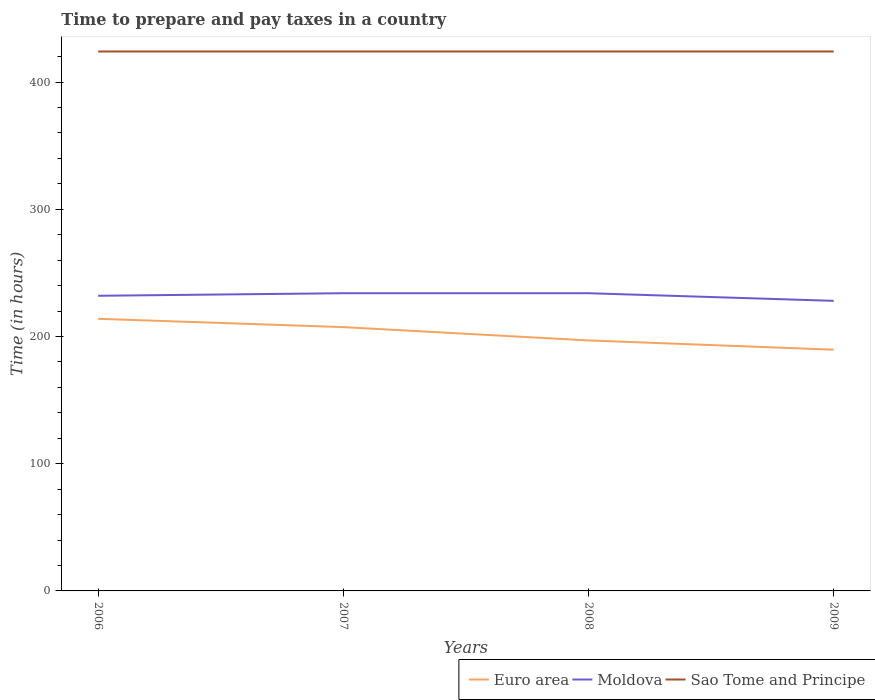Across all years, what is the maximum number of hours required to prepare and pay taxes in Euro area?
Your response must be concise. 189.61. What is the total number of hours required to prepare and pay taxes in Moldova in the graph?
Offer a terse response. -2. What is the difference between the highest and the second highest number of hours required to prepare and pay taxes in Moldova?
Provide a succinct answer. 6. How many years are there in the graph?
Your response must be concise. 4. What is the difference between two consecutive major ticks on the Y-axis?
Keep it short and to the point. 100. Are the values on the major ticks of Y-axis written in scientific E-notation?
Your answer should be very brief. No. Does the graph contain any zero values?
Offer a terse response. No. Does the graph contain grids?
Give a very brief answer. No. How many legend labels are there?
Offer a terse response. 3. How are the legend labels stacked?
Provide a succinct answer. Horizontal. What is the title of the graph?
Ensure brevity in your answer.  Time to prepare and pay taxes in a country. Does "Puerto Rico" appear as one of the legend labels in the graph?
Make the answer very short. No. What is the label or title of the X-axis?
Offer a terse response. Years. What is the label or title of the Y-axis?
Your response must be concise. Time (in hours). What is the Time (in hours) in Euro area in 2006?
Make the answer very short. 213.88. What is the Time (in hours) of Moldova in 2006?
Offer a very short reply. 232. What is the Time (in hours) in Sao Tome and Principe in 2006?
Provide a short and direct response. 424. What is the Time (in hours) of Euro area in 2007?
Your answer should be very brief. 207.35. What is the Time (in hours) in Moldova in 2007?
Give a very brief answer. 234. What is the Time (in hours) in Sao Tome and Principe in 2007?
Offer a terse response. 424. What is the Time (in hours) of Euro area in 2008?
Keep it short and to the point. 196.89. What is the Time (in hours) in Moldova in 2008?
Offer a very short reply. 234. What is the Time (in hours) of Sao Tome and Principe in 2008?
Your answer should be very brief. 424. What is the Time (in hours) in Euro area in 2009?
Ensure brevity in your answer.  189.61. What is the Time (in hours) in Moldova in 2009?
Your response must be concise. 228. What is the Time (in hours) in Sao Tome and Principe in 2009?
Provide a short and direct response. 424. Across all years, what is the maximum Time (in hours) of Euro area?
Provide a short and direct response. 213.88. Across all years, what is the maximum Time (in hours) of Moldova?
Offer a very short reply. 234. Across all years, what is the maximum Time (in hours) in Sao Tome and Principe?
Your answer should be very brief. 424. Across all years, what is the minimum Time (in hours) in Euro area?
Offer a very short reply. 189.61. Across all years, what is the minimum Time (in hours) of Moldova?
Ensure brevity in your answer.  228. Across all years, what is the minimum Time (in hours) in Sao Tome and Principe?
Provide a succinct answer. 424. What is the total Time (in hours) of Euro area in the graph?
Keep it short and to the point. 807.74. What is the total Time (in hours) of Moldova in the graph?
Your answer should be compact. 928. What is the total Time (in hours) in Sao Tome and Principe in the graph?
Your answer should be compact. 1696. What is the difference between the Time (in hours) of Euro area in 2006 and that in 2007?
Ensure brevity in your answer.  6.53. What is the difference between the Time (in hours) in Sao Tome and Principe in 2006 and that in 2007?
Offer a very short reply. 0. What is the difference between the Time (in hours) in Euro area in 2006 and that in 2008?
Keep it short and to the point. 16.99. What is the difference between the Time (in hours) in Sao Tome and Principe in 2006 and that in 2008?
Your answer should be compact. 0. What is the difference between the Time (in hours) in Euro area in 2006 and that in 2009?
Make the answer very short. 24.27. What is the difference between the Time (in hours) in Moldova in 2006 and that in 2009?
Keep it short and to the point. 4. What is the difference between the Time (in hours) of Sao Tome and Principe in 2006 and that in 2009?
Provide a short and direct response. 0. What is the difference between the Time (in hours) in Euro area in 2007 and that in 2008?
Provide a short and direct response. 10.46. What is the difference between the Time (in hours) in Moldova in 2007 and that in 2008?
Offer a very short reply. 0. What is the difference between the Time (in hours) in Sao Tome and Principe in 2007 and that in 2008?
Offer a very short reply. 0. What is the difference between the Time (in hours) of Euro area in 2007 and that in 2009?
Provide a short and direct response. 17.74. What is the difference between the Time (in hours) of Moldova in 2007 and that in 2009?
Ensure brevity in your answer.  6. What is the difference between the Time (in hours) of Sao Tome and Principe in 2007 and that in 2009?
Provide a short and direct response. 0. What is the difference between the Time (in hours) in Euro area in 2008 and that in 2009?
Your answer should be compact. 7.28. What is the difference between the Time (in hours) of Moldova in 2008 and that in 2009?
Keep it short and to the point. 6. What is the difference between the Time (in hours) in Euro area in 2006 and the Time (in hours) in Moldova in 2007?
Provide a short and direct response. -20.12. What is the difference between the Time (in hours) of Euro area in 2006 and the Time (in hours) of Sao Tome and Principe in 2007?
Offer a terse response. -210.12. What is the difference between the Time (in hours) of Moldova in 2006 and the Time (in hours) of Sao Tome and Principe in 2007?
Your response must be concise. -192. What is the difference between the Time (in hours) of Euro area in 2006 and the Time (in hours) of Moldova in 2008?
Provide a short and direct response. -20.12. What is the difference between the Time (in hours) in Euro area in 2006 and the Time (in hours) in Sao Tome and Principe in 2008?
Your response must be concise. -210.12. What is the difference between the Time (in hours) in Moldova in 2006 and the Time (in hours) in Sao Tome and Principe in 2008?
Offer a very short reply. -192. What is the difference between the Time (in hours) of Euro area in 2006 and the Time (in hours) of Moldova in 2009?
Offer a terse response. -14.12. What is the difference between the Time (in hours) in Euro area in 2006 and the Time (in hours) in Sao Tome and Principe in 2009?
Your response must be concise. -210.12. What is the difference between the Time (in hours) of Moldova in 2006 and the Time (in hours) of Sao Tome and Principe in 2009?
Offer a terse response. -192. What is the difference between the Time (in hours) in Euro area in 2007 and the Time (in hours) in Moldova in 2008?
Provide a succinct answer. -26.65. What is the difference between the Time (in hours) of Euro area in 2007 and the Time (in hours) of Sao Tome and Principe in 2008?
Offer a terse response. -216.65. What is the difference between the Time (in hours) in Moldova in 2007 and the Time (in hours) in Sao Tome and Principe in 2008?
Make the answer very short. -190. What is the difference between the Time (in hours) in Euro area in 2007 and the Time (in hours) in Moldova in 2009?
Ensure brevity in your answer.  -20.65. What is the difference between the Time (in hours) in Euro area in 2007 and the Time (in hours) in Sao Tome and Principe in 2009?
Your answer should be compact. -216.65. What is the difference between the Time (in hours) in Moldova in 2007 and the Time (in hours) in Sao Tome and Principe in 2009?
Ensure brevity in your answer.  -190. What is the difference between the Time (in hours) of Euro area in 2008 and the Time (in hours) of Moldova in 2009?
Your response must be concise. -31.11. What is the difference between the Time (in hours) of Euro area in 2008 and the Time (in hours) of Sao Tome and Principe in 2009?
Your answer should be compact. -227.11. What is the difference between the Time (in hours) of Moldova in 2008 and the Time (in hours) of Sao Tome and Principe in 2009?
Ensure brevity in your answer.  -190. What is the average Time (in hours) of Euro area per year?
Ensure brevity in your answer.  201.93. What is the average Time (in hours) of Moldova per year?
Your response must be concise. 232. What is the average Time (in hours) in Sao Tome and Principe per year?
Your answer should be very brief. 424. In the year 2006, what is the difference between the Time (in hours) in Euro area and Time (in hours) in Moldova?
Give a very brief answer. -18.12. In the year 2006, what is the difference between the Time (in hours) in Euro area and Time (in hours) in Sao Tome and Principe?
Offer a terse response. -210.12. In the year 2006, what is the difference between the Time (in hours) of Moldova and Time (in hours) of Sao Tome and Principe?
Provide a short and direct response. -192. In the year 2007, what is the difference between the Time (in hours) of Euro area and Time (in hours) of Moldova?
Provide a succinct answer. -26.65. In the year 2007, what is the difference between the Time (in hours) of Euro area and Time (in hours) of Sao Tome and Principe?
Your answer should be very brief. -216.65. In the year 2007, what is the difference between the Time (in hours) in Moldova and Time (in hours) in Sao Tome and Principe?
Your answer should be compact. -190. In the year 2008, what is the difference between the Time (in hours) in Euro area and Time (in hours) in Moldova?
Offer a terse response. -37.11. In the year 2008, what is the difference between the Time (in hours) of Euro area and Time (in hours) of Sao Tome and Principe?
Your answer should be very brief. -227.11. In the year 2008, what is the difference between the Time (in hours) of Moldova and Time (in hours) of Sao Tome and Principe?
Provide a short and direct response. -190. In the year 2009, what is the difference between the Time (in hours) in Euro area and Time (in hours) in Moldova?
Ensure brevity in your answer.  -38.39. In the year 2009, what is the difference between the Time (in hours) in Euro area and Time (in hours) in Sao Tome and Principe?
Your answer should be very brief. -234.39. In the year 2009, what is the difference between the Time (in hours) in Moldova and Time (in hours) in Sao Tome and Principe?
Your answer should be compact. -196. What is the ratio of the Time (in hours) of Euro area in 2006 to that in 2007?
Provide a succinct answer. 1.03. What is the ratio of the Time (in hours) in Sao Tome and Principe in 2006 to that in 2007?
Provide a short and direct response. 1. What is the ratio of the Time (in hours) of Euro area in 2006 to that in 2008?
Make the answer very short. 1.09. What is the ratio of the Time (in hours) of Moldova in 2006 to that in 2008?
Provide a succinct answer. 0.99. What is the ratio of the Time (in hours) of Sao Tome and Principe in 2006 to that in 2008?
Your answer should be very brief. 1. What is the ratio of the Time (in hours) in Euro area in 2006 to that in 2009?
Keep it short and to the point. 1.13. What is the ratio of the Time (in hours) in Moldova in 2006 to that in 2009?
Offer a terse response. 1.02. What is the ratio of the Time (in hours) of Euro area in 2007 to that in 2008?
Give a very brief answer. 1.05. What is the ratio of the Time (in hours) of Sao Tome and Principe in 2007 to that in 2008?
Provide a succinct answer. 1. What is the ratio of the Time (in hours) of Euro area in 2007 to that in 2009?
Ensure brevity in your answer.  1.09. What is the ratio of the Time (in hours) of Moldova in 2007 to that in 2009?
Your response must be concise. 1.03. What is the ratio of the Time (in hours) in Sao Tome and Principe in 2007 to that in 2009?
Your response must be concise. 1. What is the ratio of the Time (in hours) in Euro area in 2008 to that in 2009?
Make the answer very short. 1.04. What is the ratio of the Time (in hours) of Moldova in 2008 to that in 2009?
Your response must be concise. 1.03. What is the difference between the highest and the second highest Time (in hours) in Euro area?
Your answer should be compact. 6.53. What is the difference between the highest and the second highest Time (in hours) in Moldova?
Your answer should be compact. 0. What is the difference between the highest and the second highest Time (in hours) of Sao Tome and Principe?
Ensure brevity in your answer.  0. What is the difference between the highest and the lowest Time (in hours) of Euro area?
Provide a short and direct response. 24.27. What is the difference between the highest and the lowest Time (in hours) in Moldova?
Your response must be concise. 6. 